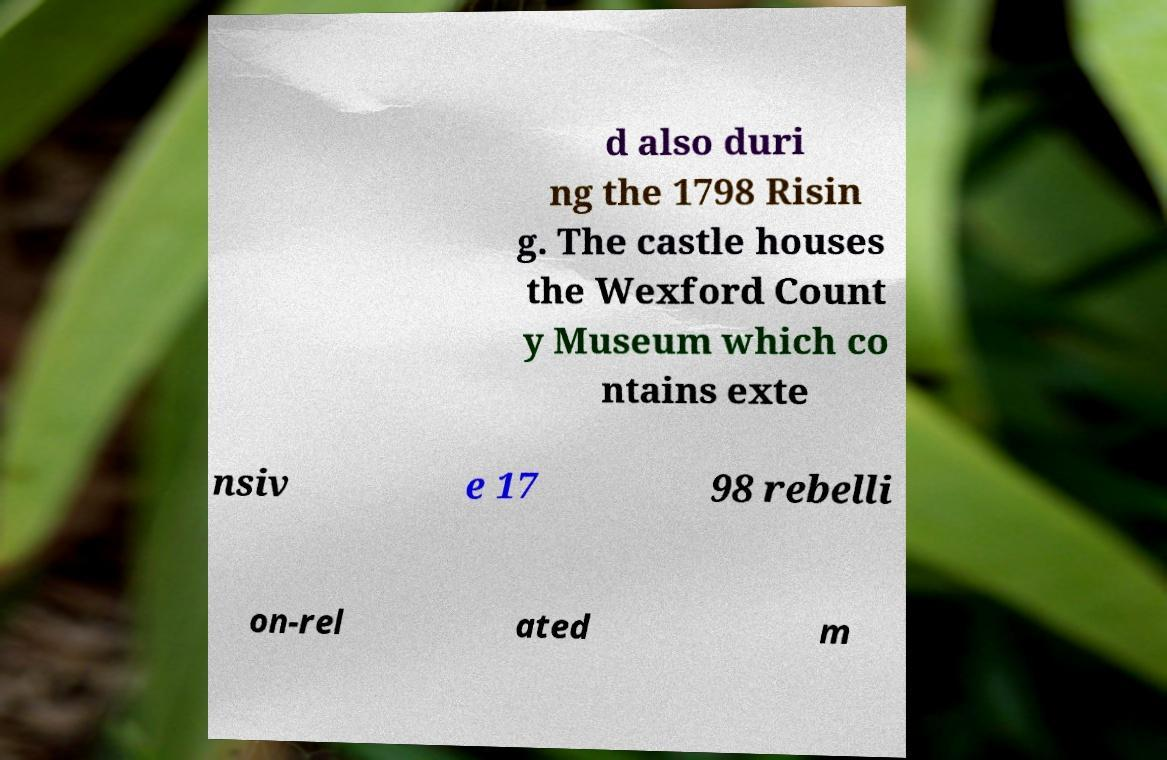What messages or text are displayed in this image? I need them in a readable, typed format. d also duri ng the 1798 Risin g. The castle houses the Wexford Count y Museum which co ntains exte nsiv e 17 98 rebelli on-rel ated m 